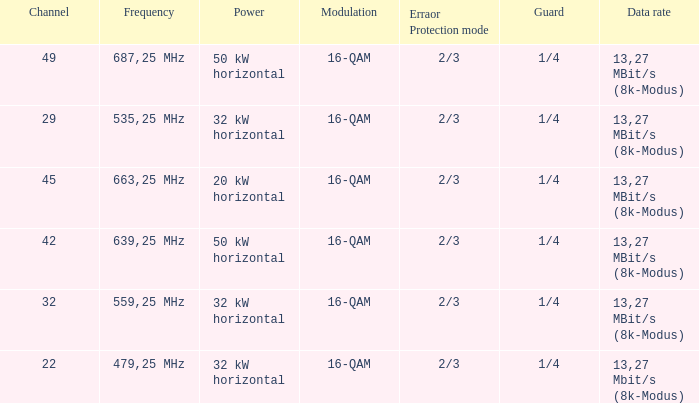On channel 32, when the power is 32 kW horizontal, what is the frequency? 559,25 MHz. 